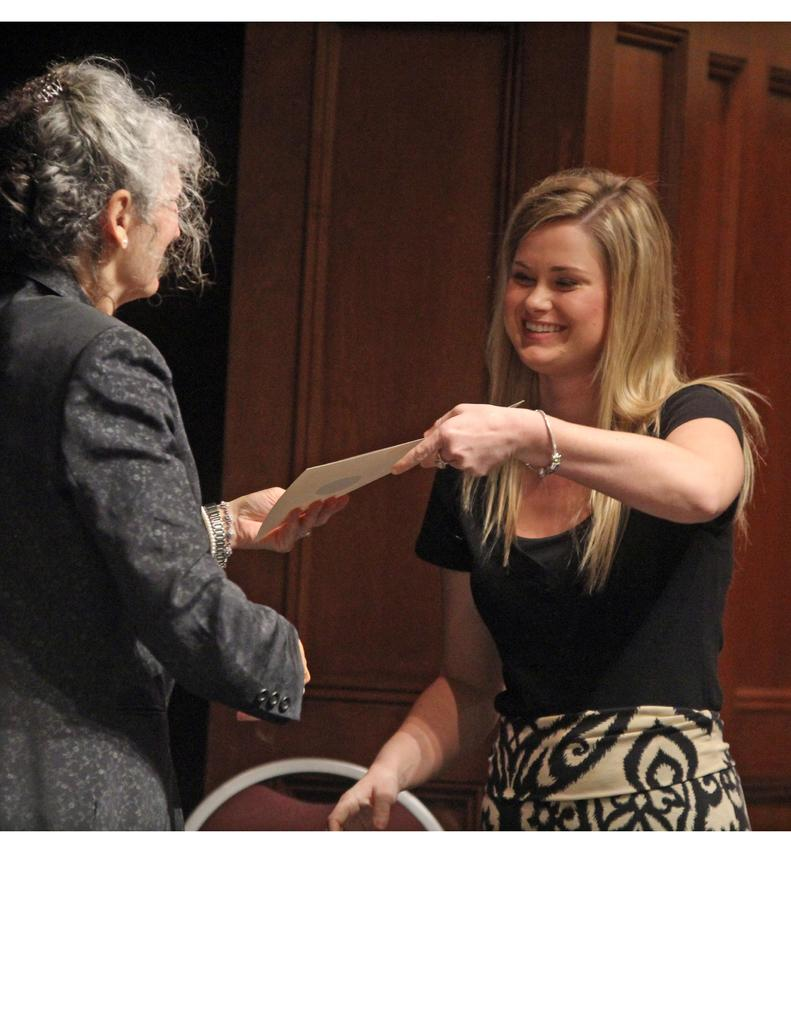How many women are present in the image? There are two women standing in the image. What are the women holding in the image? The women are holding a paper. Can you describe the facial expression of one of the women? One of the women is smiling. Is there a specific type of door visible in the image? There might be a wooden door in the image, but this is uncertain and should be considered tentative. What type of sweater is the woman wearing in the image? There is no sweater visible in the image; the women are wearing dresses. Can you tell me how many quinces are on the table in the image? There is no table or quinces present in the image. What disease is the woman discussing with the other woman in the image? There is no indication of a discussion about a disease in the image. 